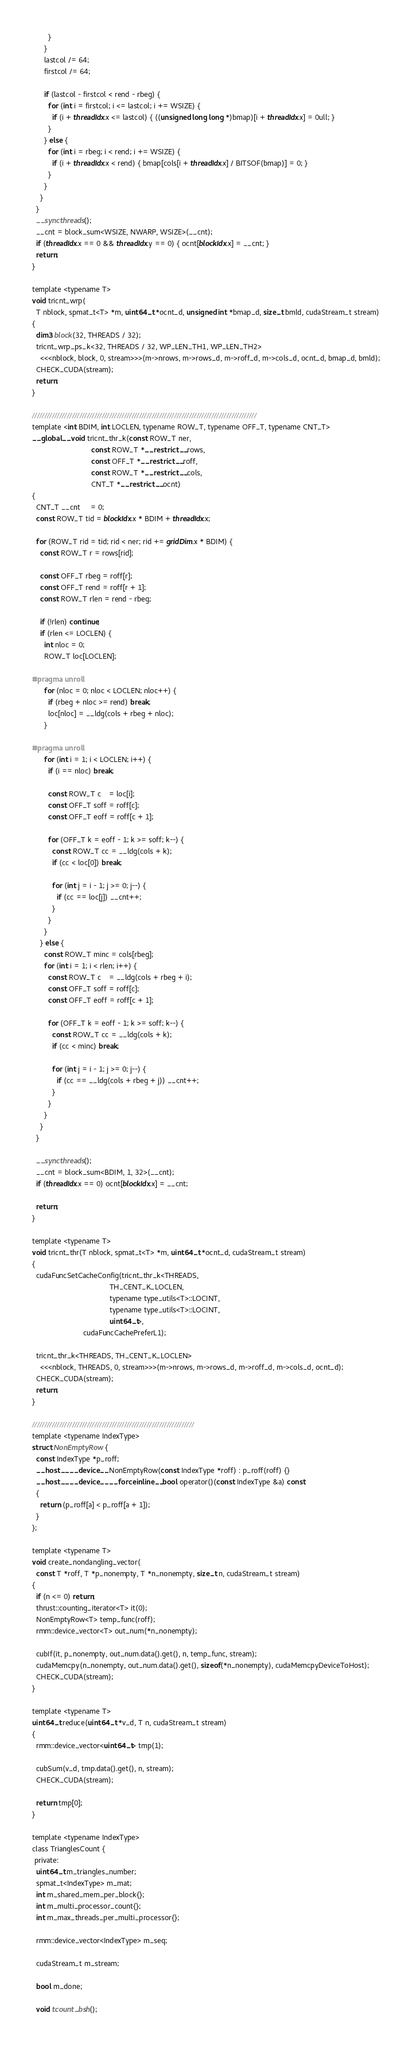<code> <loc_0><loc_0><loc_500><loc_500><_Cuda_>        }
      }
      lastcol /= 64;
      firstcol /= 64;

      if (lastcol - firstcol < rend - rbeg) {
        for (int i = firstcol; i <= lastcol; i += WSIZE) {
          if (i + threadIdx.x <= lastcol) { ((unsigned long long *)bmap)[i + threadIdx.x] = 0ull; }
        }
      } else {
        for (int i = rbeg; i < rend; i += WSIZE) {
          if (i + threadIdx.x < rend) { bmap[cols[i + threadIdx.x] / BITSOF(bmap)] = 0; }
        }
      }
    }
  }
  __syncthreads();
  __cnt = block_sum<WSIZE, NWARP, WSIZE>(__cnt);
  if (threadIdx.x == 0 && threadIdx.y == 0) { ocnt[blockIdx.x] = __cnt; }
  return;
}

template <typename T>
void tricnt_wrp(
  T nblock, spmat_t<T> *m, uint64_t *ocnt_d, unsigned int *bmap_d, size_t bmld, cudaStream_t stream)
{
  dim3 block(32, THREADS / 32);
  tricnt_wrp_ps_k<32, THREADS / 32, WP_LEN_TH1, WP_LEN_TH2>
    <<<nblock, block, 0, stream>>>(m->nrows, m->rows_d, m->roff_d, m->cols_d, ocnt_d, bmap_d, bmld);
  CHECK_CUDA(stream);
  return;
}

//////////////////////////////////////////////////////////////////////////////////////////
template <int BDIM, int LOCLEN, typename ROW_T, typename OFF_T, typename CNT_T>
__global__ void tricnt_thr_k(const ROW_T ner,
                             const ROW_T *__restrict__ rows,
                             const OFF_T *__restrict__ roff,
                             const ROW_T *__restrict__ cols,
                             CNT_T *__restrict__ ocnt)
{
  CNT_T __cnt     = 0;
  const ROW_T tid = blockIdx.x * BDIM + threadIdx.x;

  for (ROW_T rid = tid; rid < ner; rid += gridDim.x * BDIM) {
    const ROW_T r = rows[rid];

    const OFF_T rbeg = roff[r];
    const OFF_T rend = roff[r + 1];
    const ROW_T rlen = rend - rbeg;

    if (!rlen) continue;
    if (rlen <= LOCLEN) {
      int nloc = 0;
      ROW_T loc[LOCLEN];

#pragma unroll
      for (nloc = 0; nloc < LOCLEN; nloc++) {
        if (rbeg + nloc >= rend) break;
        loc[nloc] = __ldg(cols + rbeg + nloc);
      }

#pragma unroll
      for (int i = 1; i < LOCLEN; i++) {
        if (i == nloc) break;

        const ROW_T c    = loc[i];
        const OFF_T soff = roff[c];
        const OFF_T eoff = roff[c + 1];

        for (OFF_T k = eoff - 1; k >= soff; k--) {
          const ROW_T cc = __ldg(cols + k);
          if (cc < loc[0]) break;

          for (int j = i - 1; j >= 0; j--) {
            if (cc == loc[j]) __cnt++;
          }
        }
      }
    } else {
      const ROW_T minc = cols[rbeg];
      for (int i = 1; i < rlen; i++) {
        const ROW_T c    = __ldg(cols + rbeg + i);
        const OFF_T soff = roff[c];
        const OFF_T eoff = roff[c + 1];

        for (OFF_T k = eoff - 1; k >= soff; k--) {
          const ROW_T cc = __ldg(cols + k);
          if (cc < minc) break;

          for (int j = i - 1; j >= 0; j--) {
            if (cc == __ldg(cols + rbeg + j)) __cnt++;
          }
        }
      }
    }
  }

  __syncthreads();
  __cnt = block_sum<BDIM, 1, 32>(__cnt);
  if (threadIdx.x == 0) ocnt[blockIdx.x] = __cnt;

  return;
}

template <typename T>
void tricnt_thr(T nblock, spmat_t<T> *m, uint64_t *ocnt_d, cudaStream_t stream)
{
  cudaFuncSetCacheConfig(tricnt_thr_k<THREADS,
                                      TH_CENT_K_LOCLEN,
                                      typename type_utils<T>::LOCINT,
                                      typename type_utils<T>::LOCINT,
                                      uint64_t>,
                         cudaFuncCachePreferL1);

  tricnt_thr_k<THREADS, TH_CENT_K_LOCLEN>
    <<<nblock, THREADS, 0, stream>>>(m->nrows, m->rows_d, m->roff_d, m->cols_d, ocnt_d);
  CHECK_CUDA(stream);
  return;
}

/////////////////////////////////////////////////////////////////
template <typename IndexType>
struct NonEmptyRow {
  const IndexType *p_roff;
  __host__ __device__ NonEmptyRow(const IndexType *roff) : p_roff(roff) {}
  __host__ __device__ __forceinline__ bool operator()(const IndexType &a) const
  {
    return (p_roff[a] < p_roff[a + 1]);
  }
};

template <typename T>
void create_nondangling_vector(
  const T *roff, T *p_nonempty, T *n_nonempty, size_t n, cudaStream_t stream)
{
  if (n <= 0) return;
  thrust::counting_iterator<T> it(0);
  NonEmptyRow<T> temp_func(roff);
  rmm::device_vector<T> out_num(*n_nonempty);

  cubIf(it, p_nonempty, out_num.data().get(), n, temp_func, stream);
  cudaMemcpy(n_nonempty, out_num.data().get(), sizeof(*n_nonempty), cudaMemcpyDeviceToHost);
  CHECK_CUDA(stream);
}

template <typename T>
uint64_t reduce(uint64_t *v_d, T n, cudaStream_t stream)
{
  rmm::device_vector<uint64_t> tmp(1);

  cubSum(v_d, tmp.data().get(), n, stream);
  CHECK_CUDA(stream);

  return tmp[0];
}

template <typename IndexType>
class TrianglesCount {
 private:
  uint64_t m_triangles_number;
  spmat_t<IndexType> m_mat;
  int m_shared_mem_per_block{};
  int m_multi_processor_count{};
  int m_max_threads_per_multi_processor{};

  rmm::device_vector<IndexType> m_seq;

  cudaStream_t m_stream;

  bool m_done;

  void tcount_bsh();</code> 